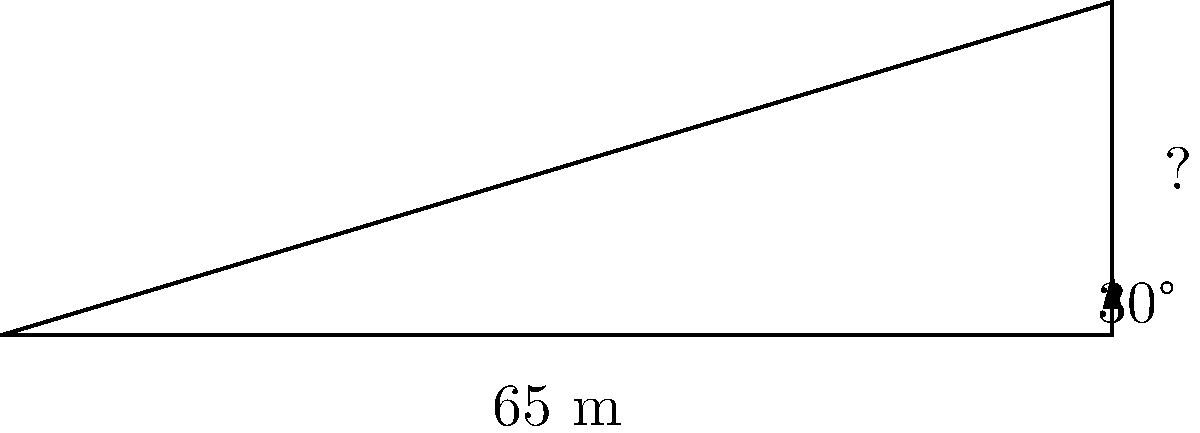A protest banner is hung between two buildings, forming a right triangle with the ground. The distance between the buildings is 65 meters, and the angle of elevation from the ground to the top of the banner is 30°. What is the height of the banner to the nearest meter? Let's approach this step-by-step:

1) We have a right triangle where:
   - The base (adjacent side) is 65 meters
   - The angle of elevation is 30°
   - We need to find the height (opposite side)

2) In this case, we can use the tangent ratio:

   $\tan \theta = \frac{\text{opposite}}{\text{adjacent}}$

3) Plugging in our known values:

   $\tan 30° = \frac{\text{height}}{65}$

4) We know that $\tan 30° = \frac{1}{\sqrt{3}} \approx 0.5774$

5) So our equation becomes:

   $0.5774 = \frac{\text{height}}{65}$

6) Multiply both sides by 65:

   $0.5774 * 65 = \text{height}$

7) Calculate:

   $\text{height} = 37.531$ meters

8) Rounding to the nearest meter:

   $\text{height} \approx 38$ meters

Thus, the height of the protest banner is approximately 38 meters.
Answer: 38 meters 